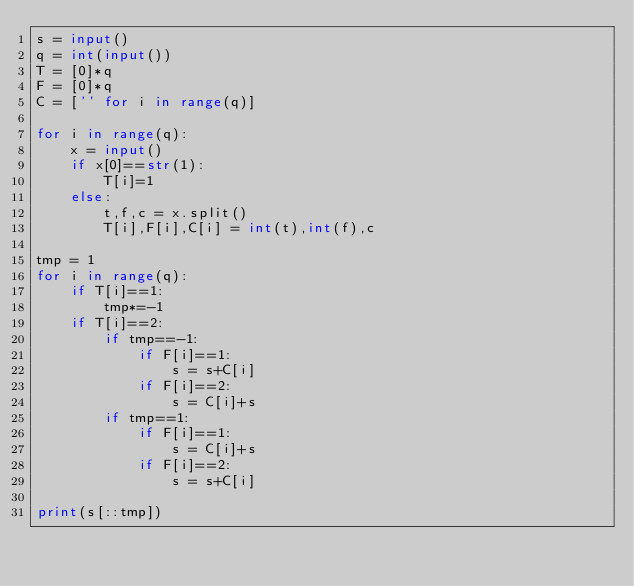Convert code to text. <code><loc_0><loc_0><loc_500><loc_500><_Python_>s = input()
q = int(input())
T = [0]*q
F = [0]*q
C = ['' for i in range(q)]

for i in range(q):
    x = input()
    if x[0]==str(1):
        T[i]=1
    else:
        t,f,c = x.split()
        T[i],F[i],C[i] = int(t),int(f),c

tmp = 1
for i in range(q):
    if T[i]==1:
        tmp*=-1
    if T[i]==2:
        if tmp==-1:
            if F[i]==1:
                s = s+C[i]
            if F[i]==2:
                s = C[i]+s
        if tmp==1:
            if F[i]==1:
                s = C[i]+s
            if F[i]==2:
                s = s+C[i]

print(s[::tmp])</code> 